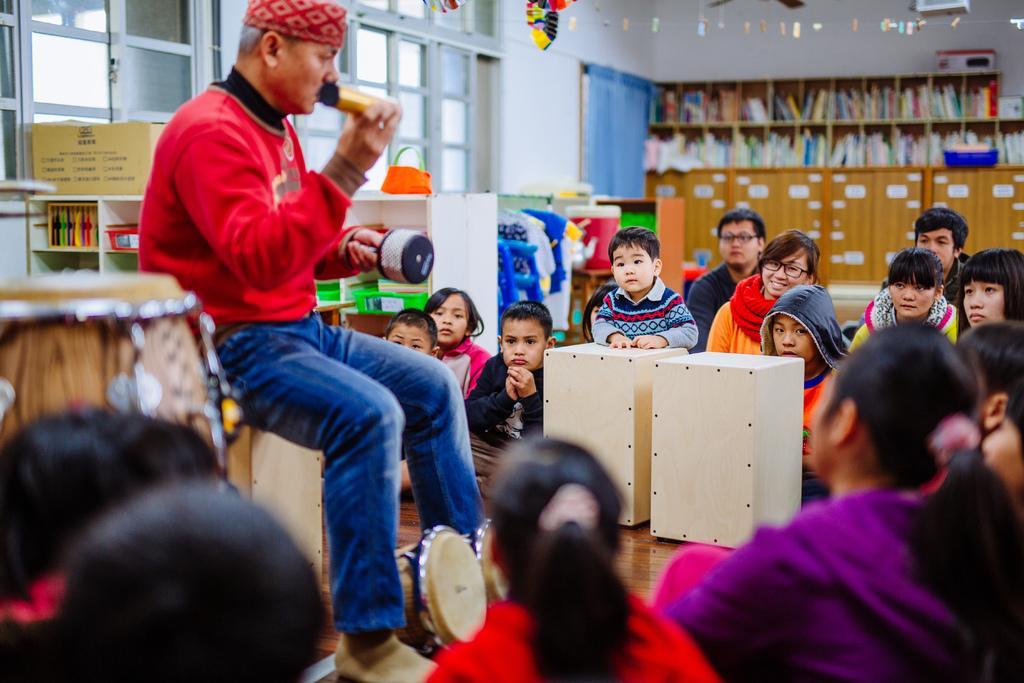Could you give a brief overview of what you see in this image? Then image is inside the room. In the image on left side there is a man sitting and holding something on his hand and there are group of people around him, in background there is a table books on shelf,curtains,windows. 